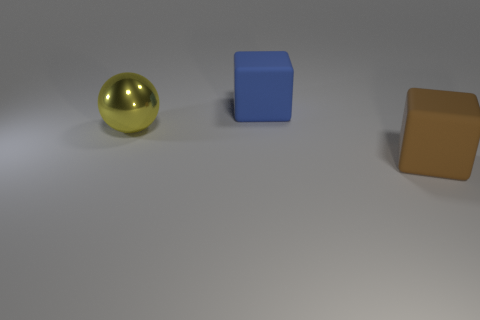Are there any other things that are the same material as the big yellow ball?
Ensure brevity in your answer.  No. Is the large blue thing the same shape as the big brown object?
Make the answer very short. Yes. What number of yellow balls are the same material as the yellow object?
Offer a very short reply. 0. There is a large object to the right of the big block that is behind the big thing in front of the yellow metallic object; what shape is it?
Provide a short and direct response. Cube. There is another thing that is the same shape as the large blue matte object; what color is it?
Ensure brevity in your answer.  Brown. There is a thing that is both behind the big brown object and in front of the big blue matte thing; what size is it?
Provide a succinct answer. Large. What number of big metallic balls are behind the matte object in front of the large block behind the big brown cube?
Provide a succinct answer. 1. What number of small things are either blue objects or metal objects?
Provide a short and direct response. 0. Is the cube on the left side of the brown object made of the same material as the big brown thing?
Ensure brevity in your answer.  Yes. What material is the big cube that is to the left of the rubber block on the right side of the big cube behind the big ball?
Your answer should be very brief. Rubber. 